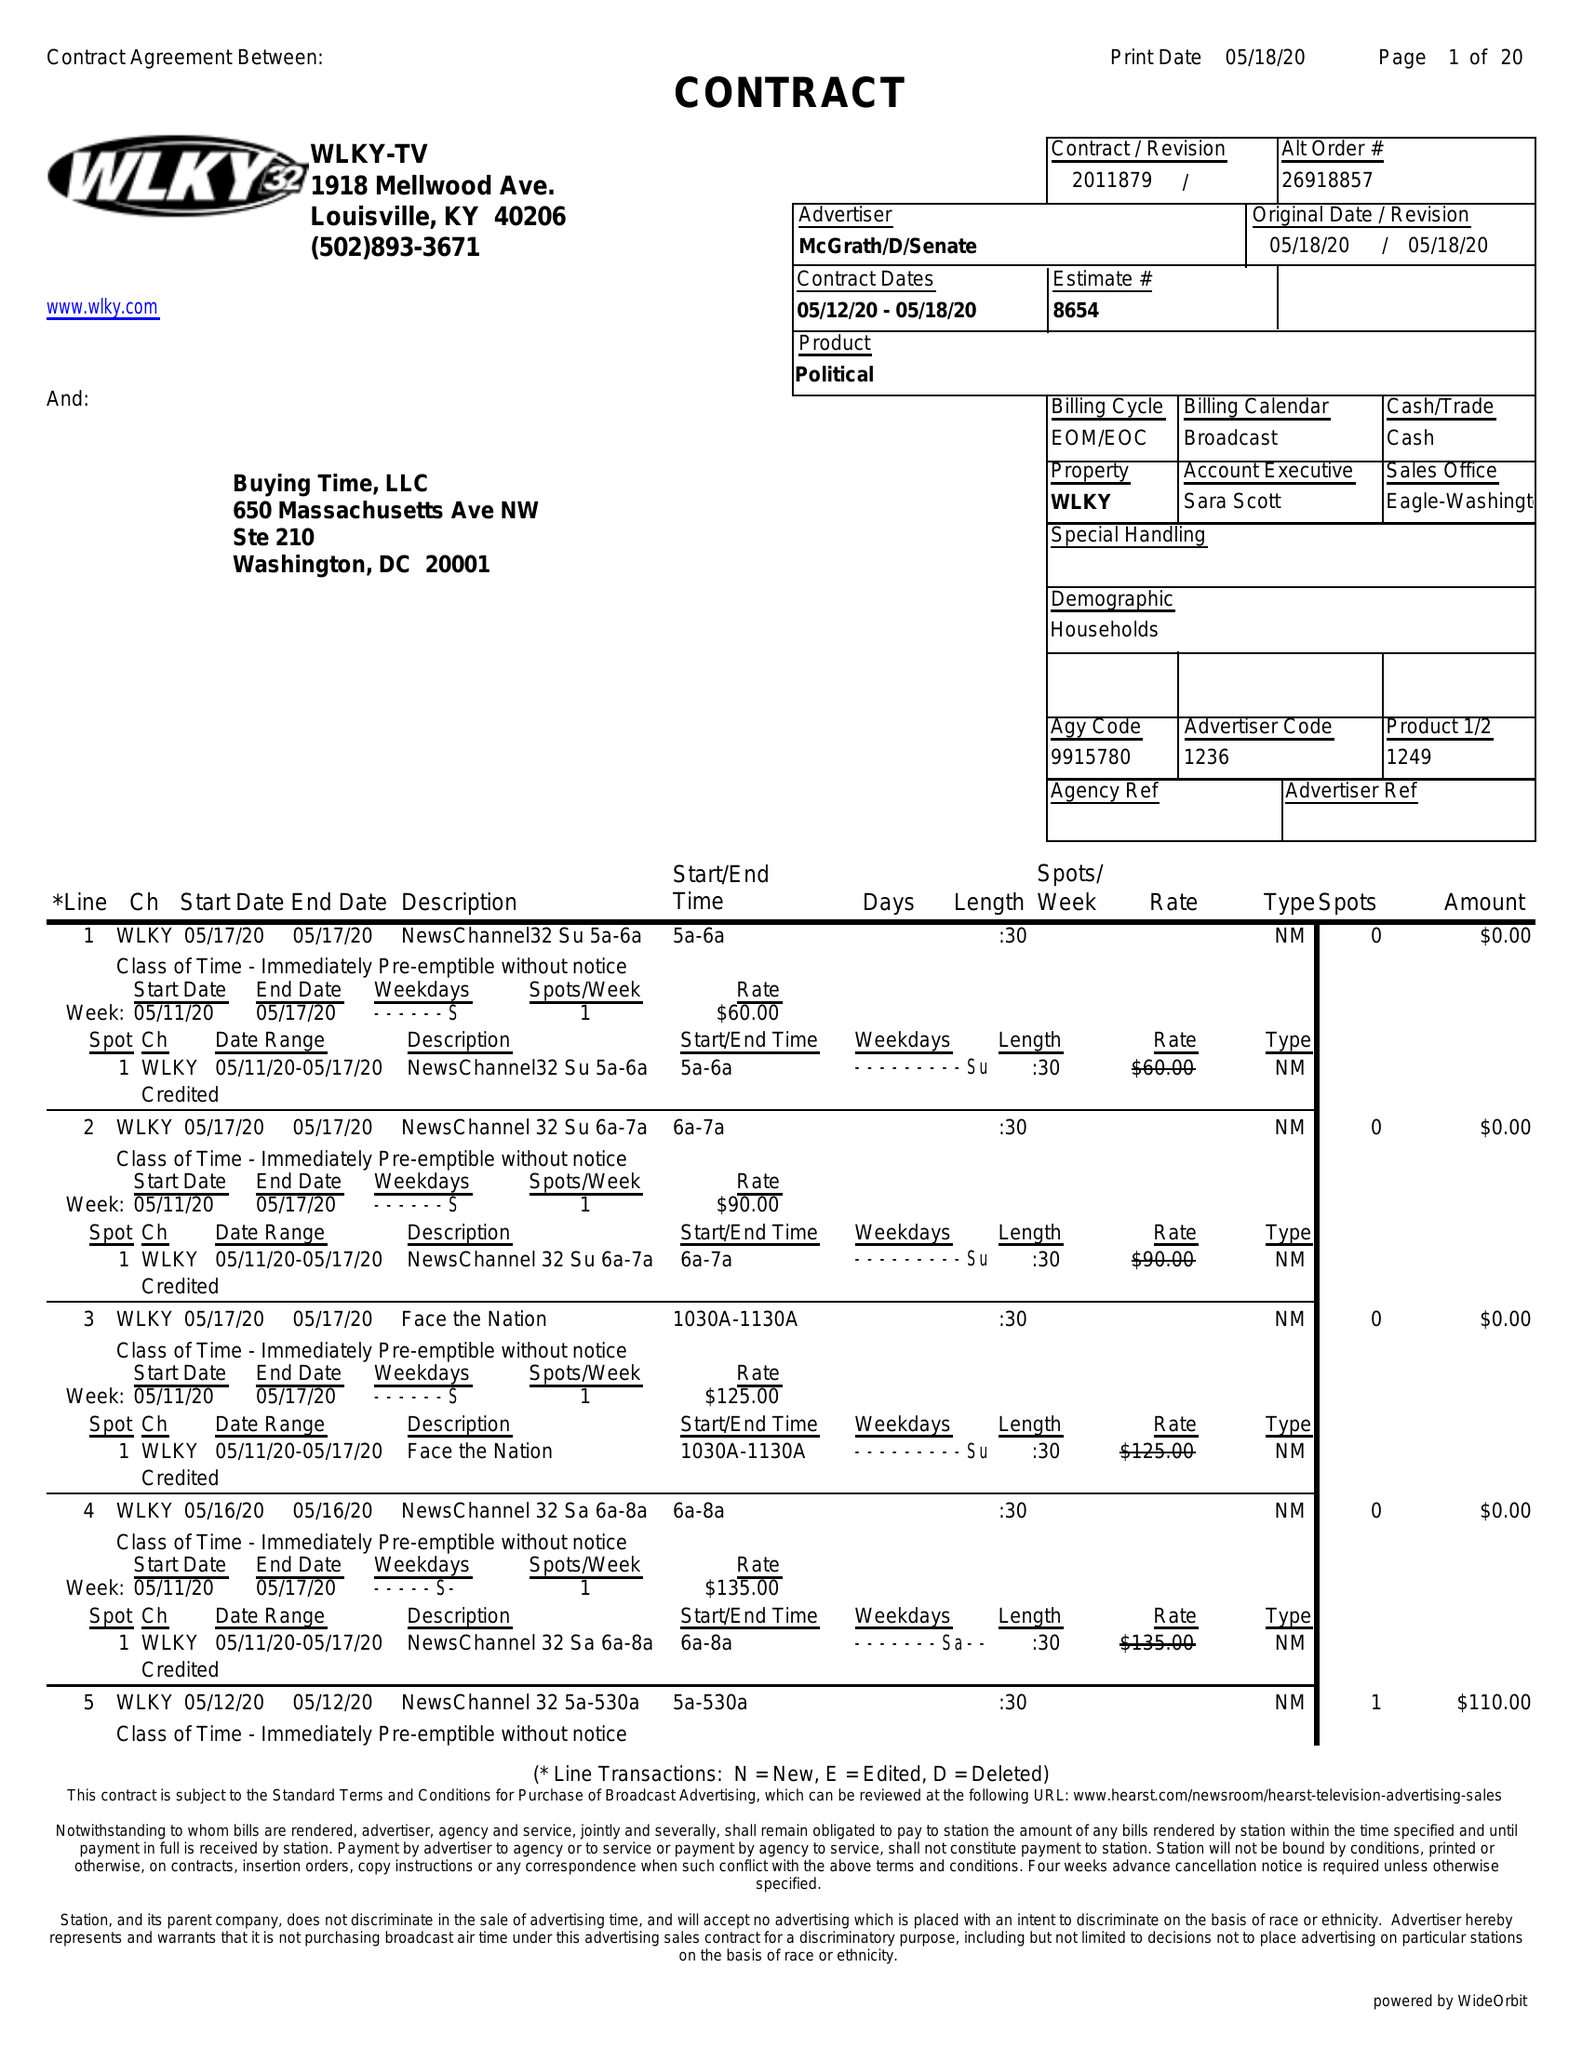What is the value for the advertiser?
Answer the question using a single word or phrase. MCGRATH/D/SENATE 